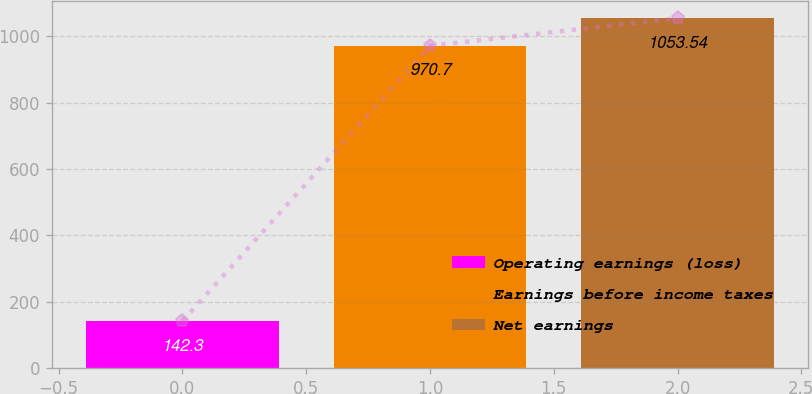Convert chart to OTSL. <chart><loc_0><loc_0><loc_500><loc_500><bar_chart><fcel>Operating earnings (loss)<fcel>Earnings before income taxes<fcel>Net earnings<nl><fcel>142.3<fcel>970.7<fcel>1053.54<nl></chart> 